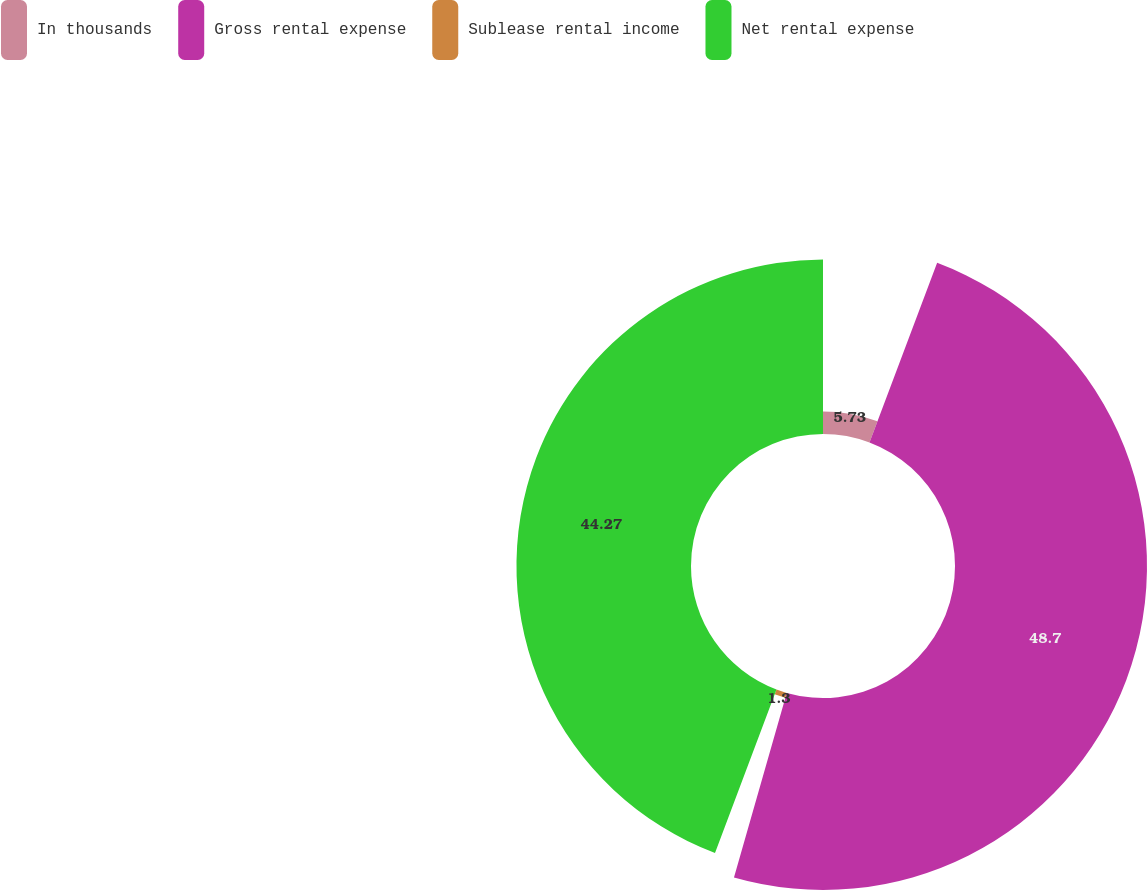<chart> <loc_0><loc_0><loc_500><loc_500><pie_chart><fcel>In thousands<fcel>Gross rental expense<fcel>Sublease rental income<fcel>Net rental expense<nl><fcel>5.73%<fcel>48.7%<fcel>1.3%<fcel>44.27%<nl></chart> 